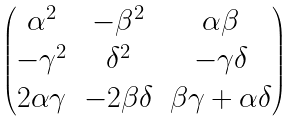Convert formula to latex. <formula><loc_0><loc_0><loc_500><loc_500>\begin{pmatrix} \alpha ^ { 2 } & - \beta ^ { 2 } & \alpha \beta \\ - \gamma ^ { 2 } & \delta ^ { 2 } & - \gamma \delta \\ 2 \alpha \gamma & - 2 \beta \delta & \beta \gamma + \alpha \delta \end{pmatrix}</formula> 